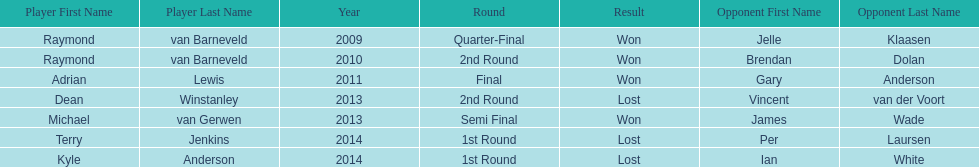Who are the only players listed that played in 2011? Adrian Lewis. 